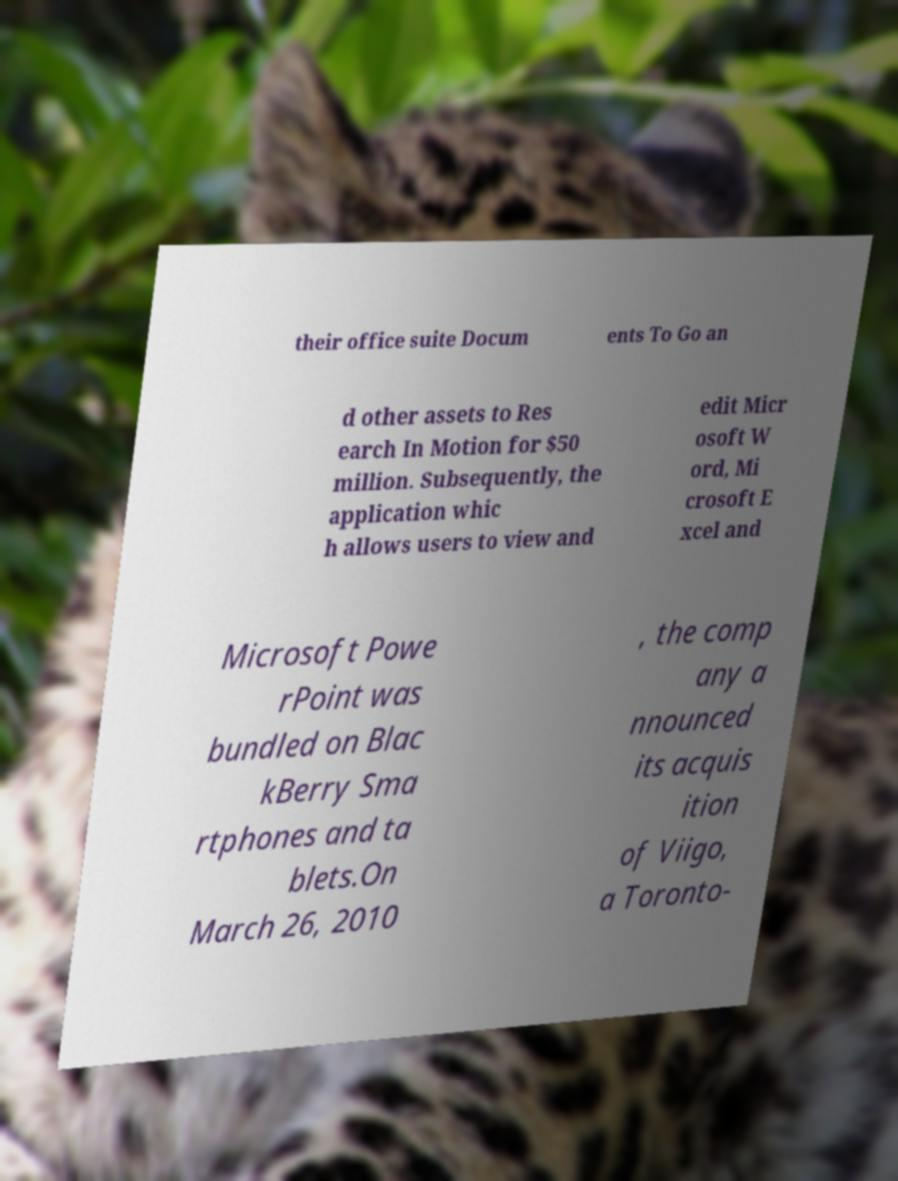There's text embedded in this image that I need extracted. Can you transcribe it verbatim? their office suite Docum ents To Go an d other assets to Res earch In Motion for $50 million. Subsequently, the application whic h allows users to view and edit Micr osoft W ord, Mi crosoft E xcel and Microsoft Powe rPoint was bundled on Blac kBerry Sma rtphones and ta blets.On March 26, 2010 , the comp any a nnounced its acquis ition of Viigo, a Toronto- 